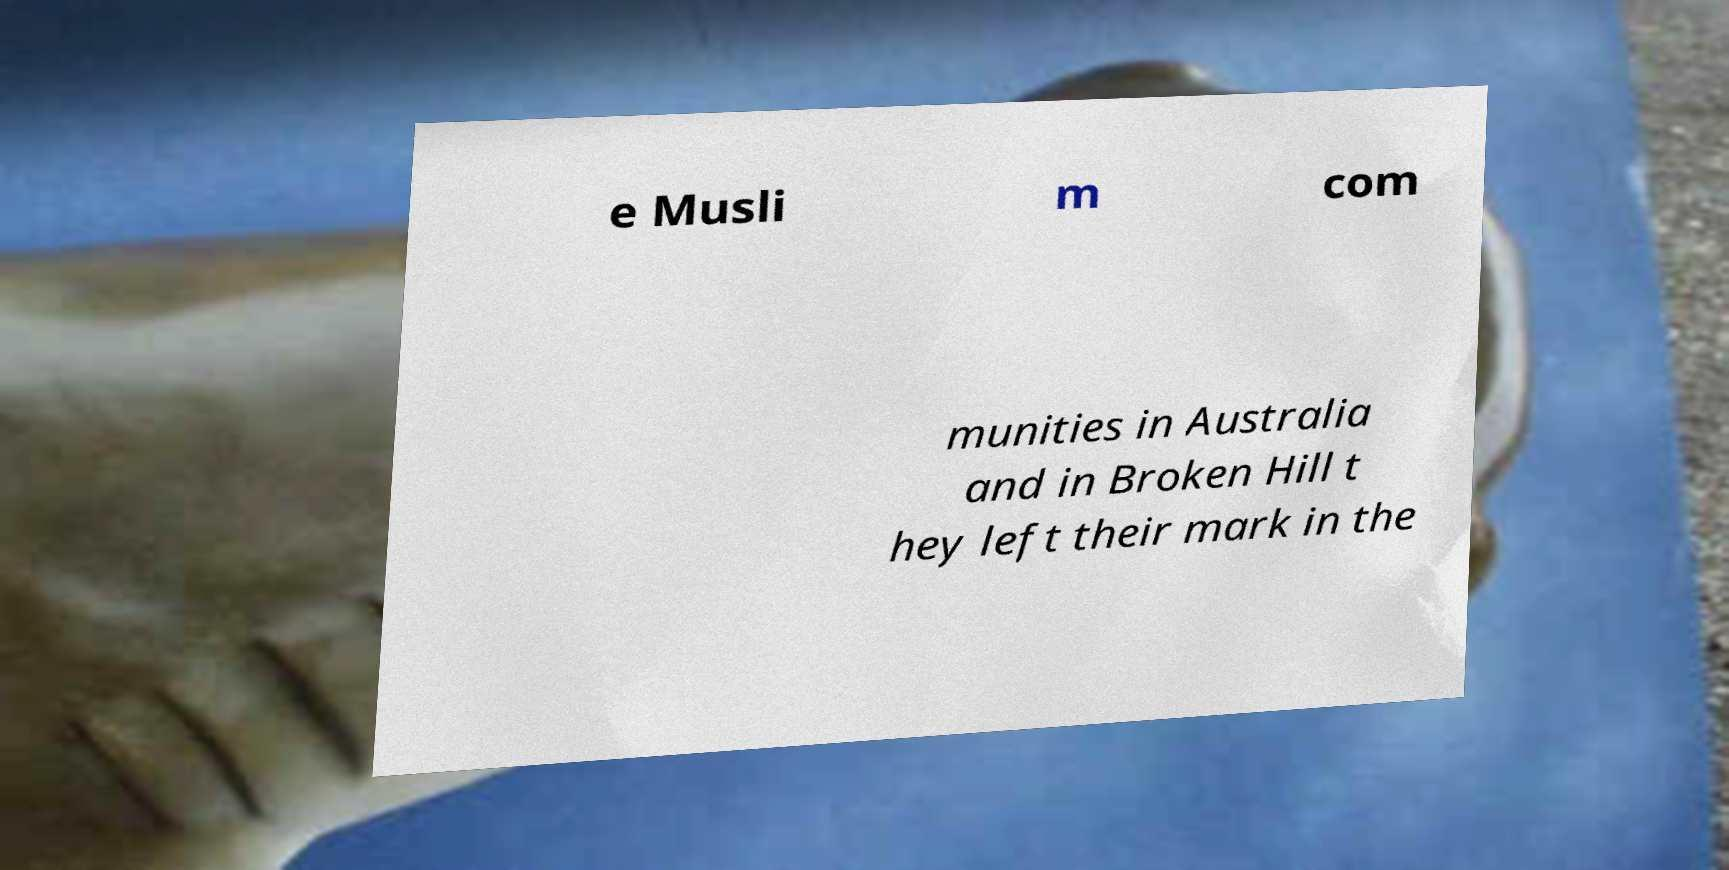Please identify and transcribe the text found in this image. e Musli m com munities in Australia and in Broken Hill t hey left their mark in the 